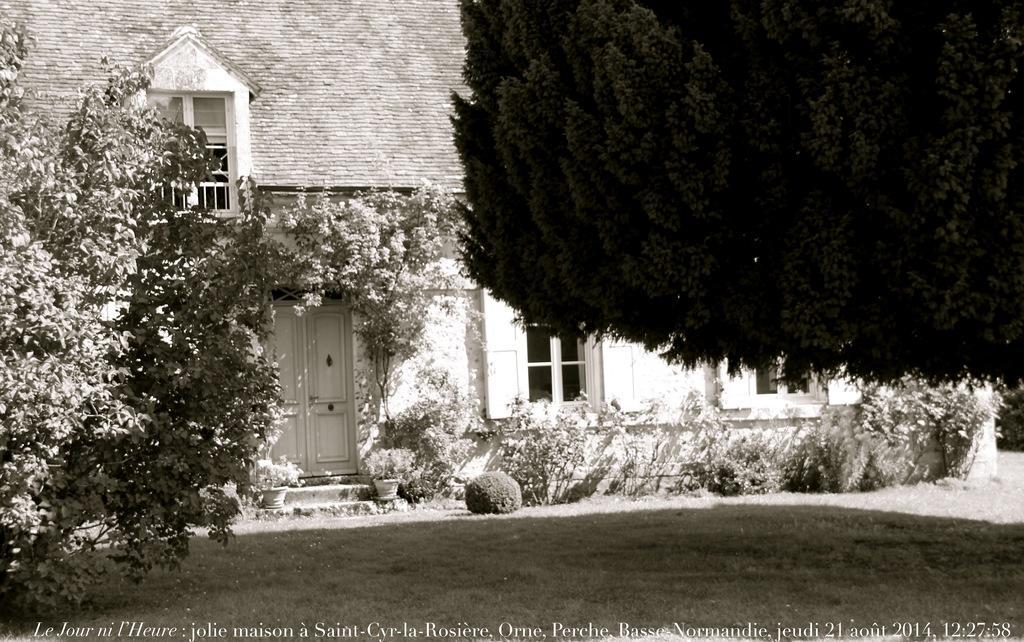Can you describe this image briefly? This is a black and white image. In this image we can see building, windows, door, trees, house plants, shrubs, plants and ground. 